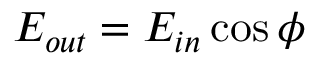Convert formula to latex. <formula><loc_0><loc_0><loc_500><loc_500>E _ { o u t } = E _ { i n } \cos \phi</formula> 